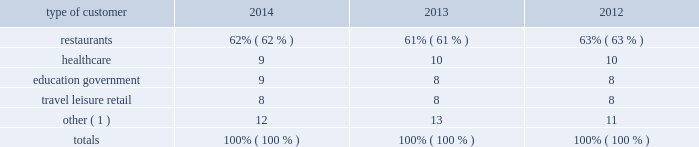Sysco corporation a0- a0form a010-k 3 part a0i item a01 a0business our distribution centers , which we refer to as operating companies , distribute nationally-branded merchandise , as well as products packaged under our private brands .
Products packaged under our private brands have been manufactured for sysco according to specifi cations that have been developed by our quality assurance team .
In addition , our quality assurance team certifi es the manufacturing and processing plants where these products are packaged , enforces our quality control standards and identifi es supply sources that satisfy our requirements .
We believe that prompt and accurate delivery of orders , competitive pricing , close contact with customers and the ability to provide a full array of products and services to assist customers in their foodservice operations are of primary importance in the marketing and distribution of foodservice products to our customers .
Our operating companies offer daily delivery to certain customer locations and have the capability of delivering special orders on short notice .
Through our approximately 12800 sales and marketing representatives and support staff of sysco and our operating companies , we stay informed of the needs of our customers and acquaint them with new products and services .
Our operating companies also provide ancillary services relating to foodservice distribution , such as providing customers with product usage reports and other data , menu-planning advice , food safety training and assistance in inventory control , as well as access to various third party services designed to add value to our customers 2019 businesses .
No single customer accounted for 10% ( 10 % ) or more of sysco 2019s total sales for the fi scal year ended june 28 , 2014 .
We estimate that our sales by type of customer during the past three fi scal years were as follows: .
( 1 ) other includes cafeterias that are not stand alone restaurants , bakeries , caterers , churches , civic and fraternal organizations , vending distributors , other distributors and international exports .
None of these types of customers , as a group , exceeded 5% ( 5 % ) of total sales in any of the years for which information is presented .
Sources of supply we purchase from thousands of suppliers , both domestic and international , none of which individually accounts for more than 10% ( 10 % ) of our purchases .
These suppliers consist generally of large corporations selling brand name and private label merchandise , as well as independent regional brand and private label processors and packers .
Purchasing is generally carried out through both centrally developed purchasing programs and direct purchasing programs established by our various operating companies .
We administer a consolidated product procurement program designed to develop , obtain and ensure consistent quality food and non-food products .
The program covers the purchasing and marketing of sysco brand merchandise , as well as products from a number of national brand suppliers , encompassing substantially all product lines .
Sysco 2019s operating companies purchase product from the suppliers participating in these consolidated programs and from other suppliers , although sysco brand products are only available to the operating companies through these consolidated programs .
We also focus on increasing profi tability by lowering operating costs and by lowering aggregate inventory levels , which reduces future facility expansion needs at our broadline operating companies , while providing greater value to our suppliers and customers .
This includes the construction and operation of regional distribution centers ( rdcs ) , which aggregate inventory demand to optimize the supply chain activities for certain products for all sysco broadline operating companies in the region .
Currently , we have two rdcs in operation , one in virginia and one in florida .
Working capital practices our growth is funded through a combination of cash fl ow from operations , commercial paper issuances and long-term borrowings .
See the discussion in 201cmanagement 2019s discussion and analysis of financial condition and results of operations , liquidity and capital resources 201d at item 7 regarding our liquidity , fi nancial position and sources and uses of funds .
Credit terms we extend to our customers can vary from cash on delivery to 30 days or more based on our assessment of each customer 2019s credit worthiness .
We monitor each customer 2019s account and will suspend shipments if necessary .
A majority of our sales orders are fi lled within 24 hours of when customer orders are placed .
We generally maintain inventory on hand to be able to meet customer demand .
The level of inventory on hand will vary by product depending on shelf-life , supplier order fulfi llment lead times and customer demand .
We also make purchases of additional volumes of certain products based on supply or pricing opportunities .
We take advantage of suppliers 2019 cash discounts where appropriate and otherwise generally receive payment terms from our suppliers ranging from weekly to 30 days or more. .
What was the change in restaurants percentage of sales from 2012 to 2013? 
Computations: (61% - 63%)
Answer: -0.02. Sysco corporation a0- a0form a010-k 3 part a0i item a01 a0business our distribution centers , which we refer to as operating companies , distribute nationally-branded merchandise , as well as products packaged under our private brands .
Products packaged under our private brands have been manufactured for sysco according to specifi cations that have been developed by our quality assurance team .
In addition , our quality assurance team certifi es the manufacturing and processing plants where these products are packaged , enforces our quality control standards and identifi es supply sources that satisfy our requirements .
We believe that prompt and accurate delivery of orders , competitive pricing , close contact with customers and the ability to provide a full array of products and services to assist customers in their foodservice operations are of primary importance in the marketing and distribution of foodservice products to our customers .
Our operating companies offer daily delivery to certain customer locations and have the capability of delivering special orders on short notice .
Through our approximately 12800 sales and marketing representatives and support staff of sysco and our operating companies , we stay informed of the needs of our customers and acquaint them with new products and services .
Our operating companies also provide ancillary services relating to foodservice distribution , such as providing customers with product usage reports and other data , menu-planning advice , food safety training and assistance in inventory control , as well as access to various third party services designed to add value to our customers 2019 businesses .
No single customer accounted for 10% ( 10 % ) or more of sysco 2019s total sales for the fi scal year ended june 28 , 2014 .
We estimate that our sales by type of customer during the past three fi scal years were as follows: .
( 1 ) other includes cafeterias that are not stand alone restaurants , bakeries , caterers , churches , civic and fraternal organizations , vending distributors , other distributors and international exports .
None of these types of customers , as a group , exceeded 5% ( 5 % ) of total sales in any of the years for which information is presented .
Sources of supply we purchase from thousands of suppliers , both domestic and international , none of which individually accounts for more than 10% ( 10 % ) of our purchases .
These suppliers consist generally of large corporations selling brand name and private label merchandise , as well as independent regional brand and private label processors and packers .
Purchasing is generally carried out through both centrally developed purchasing programs and direct purchasing programs established by our various operating companies .
We administer a consolidated product procurement program designed to develop , obtain and ensure consistent quality food and non-food products .
The program covers the purchasing and marketing of sysco brand merchandise , as well as products from a number of national brand suppliers , encompassing substantially all product lines .
Sysco 2019s operating companies purchase product from the suppliers participating in these consolidated programs and from other suppliers , although sysco brand products are only available to the operating companies through these consolidated programs .
We also focus on increasing profi tability by lowering operating costs and by lowering aggregate inventory levels , which reduces future facility expansion needs at our broadline operating companies , while providing greater value to our suppliers and customers .
This includes the construction and operation of regional distribution centers ( rdcs ) , which aggregate inventory demand to optimize the supply chain activities for certain products for all sysco broadline operating companies in the region .
Currently , we have two rdcs in operation , one in virginia and one in florida .
Working capital practices our growth is funded through a combination of cash fl ow from operations , commercial paper issuances and long-term borrowings .
See the discussion in 201cmanagement 2019s discussion and analysis of financial condition and results of operations , liquidity and capital resources 201d at item 7 regarding our liquidity , fi nancial position and sources and uses of funds .
Credit terms we extend to our customers can vary from cash on delivery to 30 days or more based on our assessment of each customer 2019s credit worthiness .
We monitor each customer 2019s account and will suspend shipments if necessary .
A majority of our sales orders are fi lled within 24 hours of when customer orders are placed .
We generally maintain inventory on hand to be able to meet customer demand .
The level of inventory on hand will vary by product depending on shelf-life , supplier order fulfi llment lead times and customer demand .
We also make purchases of additional volumes of certain products based on supply or pricing opportunities .
We take advantage of suppliers 2019 cash discounts where appropriate and otherwise generally receive payment terms from our suppliers ranging from weekly to 30 days or more. .
What was the change in restaurants percentage of sales from 2013 to 2014? 
Computations: (62% - 61%)
Answer: 0.01. 